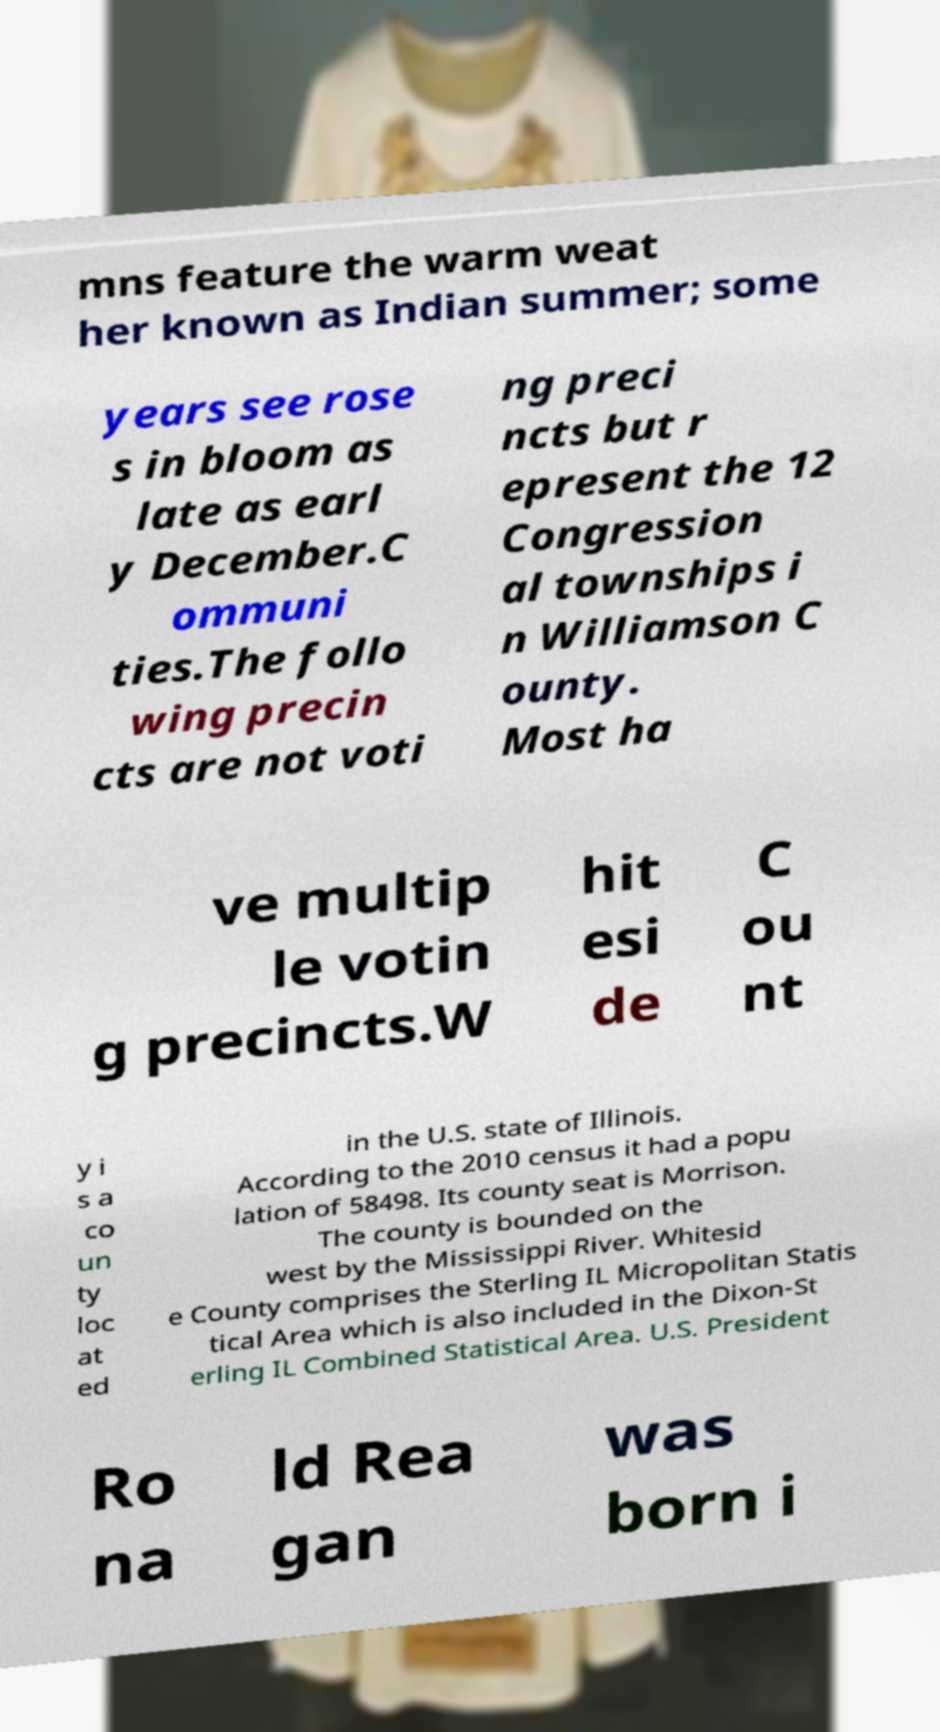Could you assist in decoding the text presented in this image and type it out clearly? mns feature the warm weat her known as Indian summer; some years see rose s in bloom as late as earl y December.C ommuni ties.The follo wing precin cts are not voti ng preci ncts but r epresent the 12 Congression al townships i n Williamson C ounty. Most ha ve multip le votin g precincts.W hit esi de C ou nt y i s a co un ty loc at ed in the U.S. state of Illinois. According to the 2010 census it had a popu lation of 58498. Its county seat is Morrison. The county is bounded on the west by the Mississippi River. Whitesid e County comprises the Sterling IL Micropolitan Statis tical Area which is also included in the Dixon-St erling IL Combined Statistical Area. U.S. President Ro na ld Rea gan was born i 